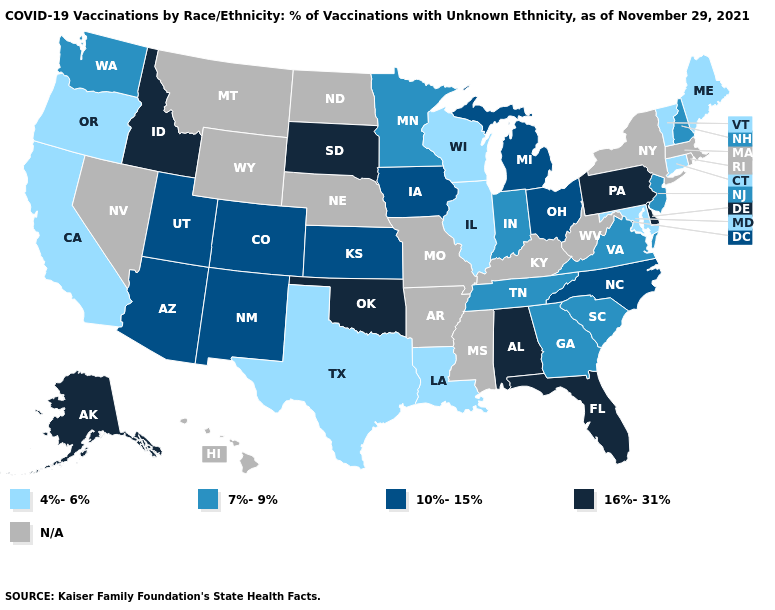What is the lowest value in the Northeast?
Be succinct. 4%-6%. What is the value of Ohio?
Quick response, please. 10%-15%. Among the states that border Indiana , which have the lowest value?
Answer briefly. Illinois. What is the value of Nevada?
Answer briefly. N/A. How many symbols are there in the legend?
Keep it brief. 5. Does the map have missing data?
Be succinct. Yes. What is the value of Utah?
Short answer required. 10%-15%. Name the states that have a value in the range N/A?
Write a very short answer. Arkansas, Hawaii, Kentucky, Massachusetts, Mississippi, Missouri, Montana, Nebraska, Nevada, New York, North Dakota, Rhode Island, West Virginia, Wyoming. How many symbols are there in the legend?
Answer briefly. 5. Among the states that border South Dakota , which have the highest value?
Write a very short answer. Iowa. Name the states that have a value in the range 10%-15%?
Short answer required. Arizona, Colorado, Iowa, Kansas, Michigan, New Mexico, North Carolina, Ohio, Utah. Among the states that border Wisconsin , does Michigan have the lowest value?
Write a very short answer. No. Which states have the highest value in the USA?
Write a very short answer. Alabama, Alaska, Delaware, Florida, Idaho, Oklahoma, Pennsylvania, South Dakota. Among the states that border Delaware , which have the lowest value?
Concise answer only. Maryland. Which states have the lowest value in the Northeast?
Answer briefly. Connecticut, Maine, Vermont. 